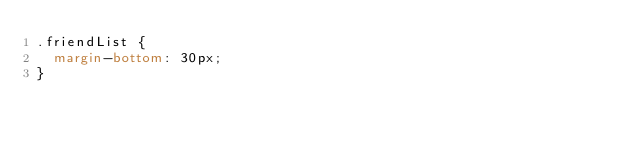<code> <loc_0><loc_0><loc_500><loc_500><_CSS_>.friendList {
  margin-bottom: 30px;
}
</code> 